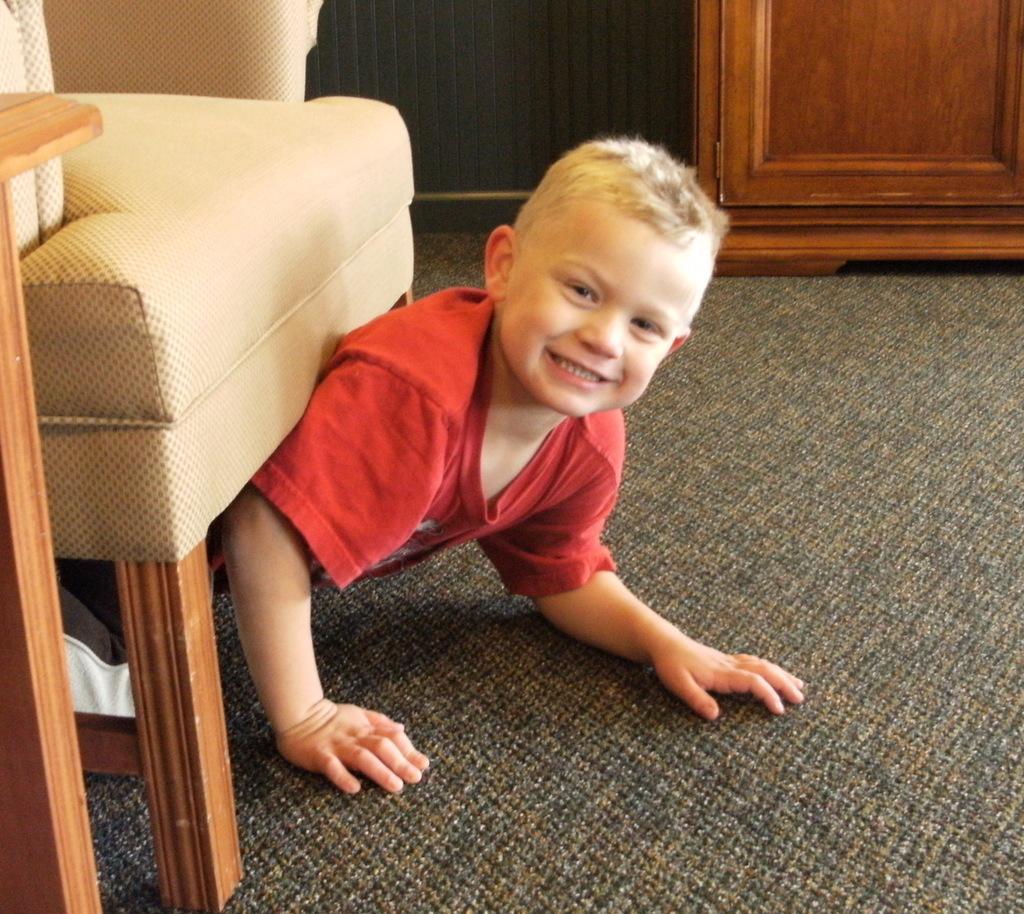Could you give a brief overview of what you see in this image? The kid wearing a red shirt is crawling under the chair and the ground has a mat on it. 